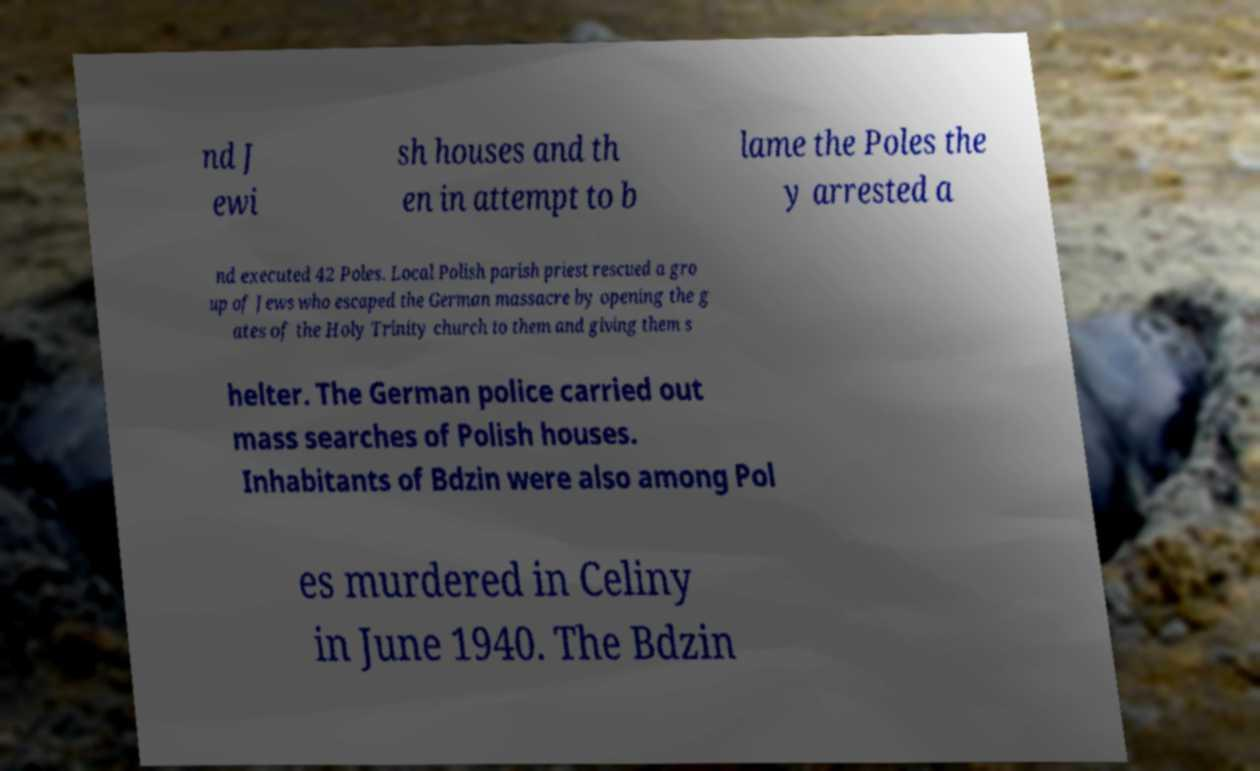Please read and relay the text visible in this image. What does it say? nd J ewi sh houses and th en in attempt to b lame the Poles the y arrested a nd executed 42 Poles. Local Polish parish priest rescued a gro up of Jews who escaped the German massacre by opening the g ates of the Holy Trinity church to them and giving them s helter. The German police carried out mass searches of Polish houses. Inhabitants of Bdzin were also among Pol es murdered in Celiny in June 1940. The Bdzin 